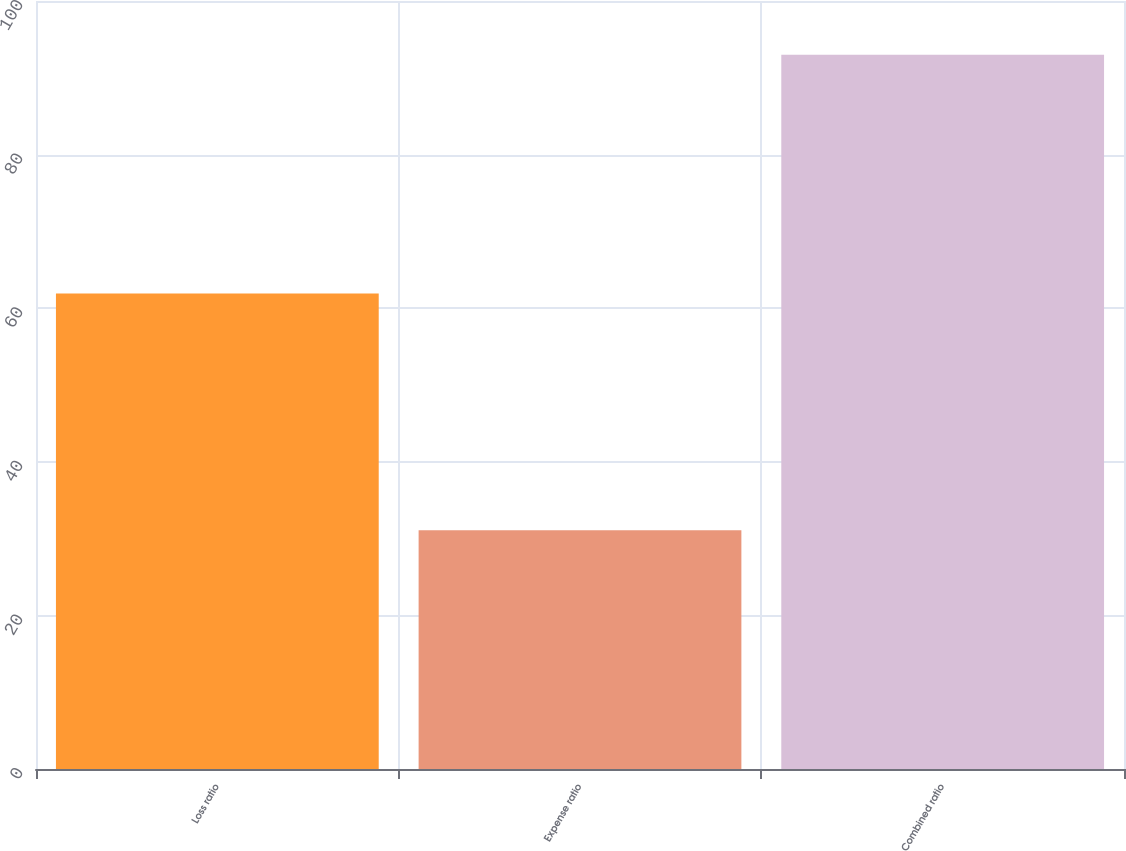Convert chart to OTSL. <chart><loc_0><loc_0><loc_500><loc_500><bar_chart><fcel>Loss ratio<fcel>Expense ratio<fcel>Combined ratio<nl><fcel>61.9<fcel>31.1<fcel>93<nl></chart> 